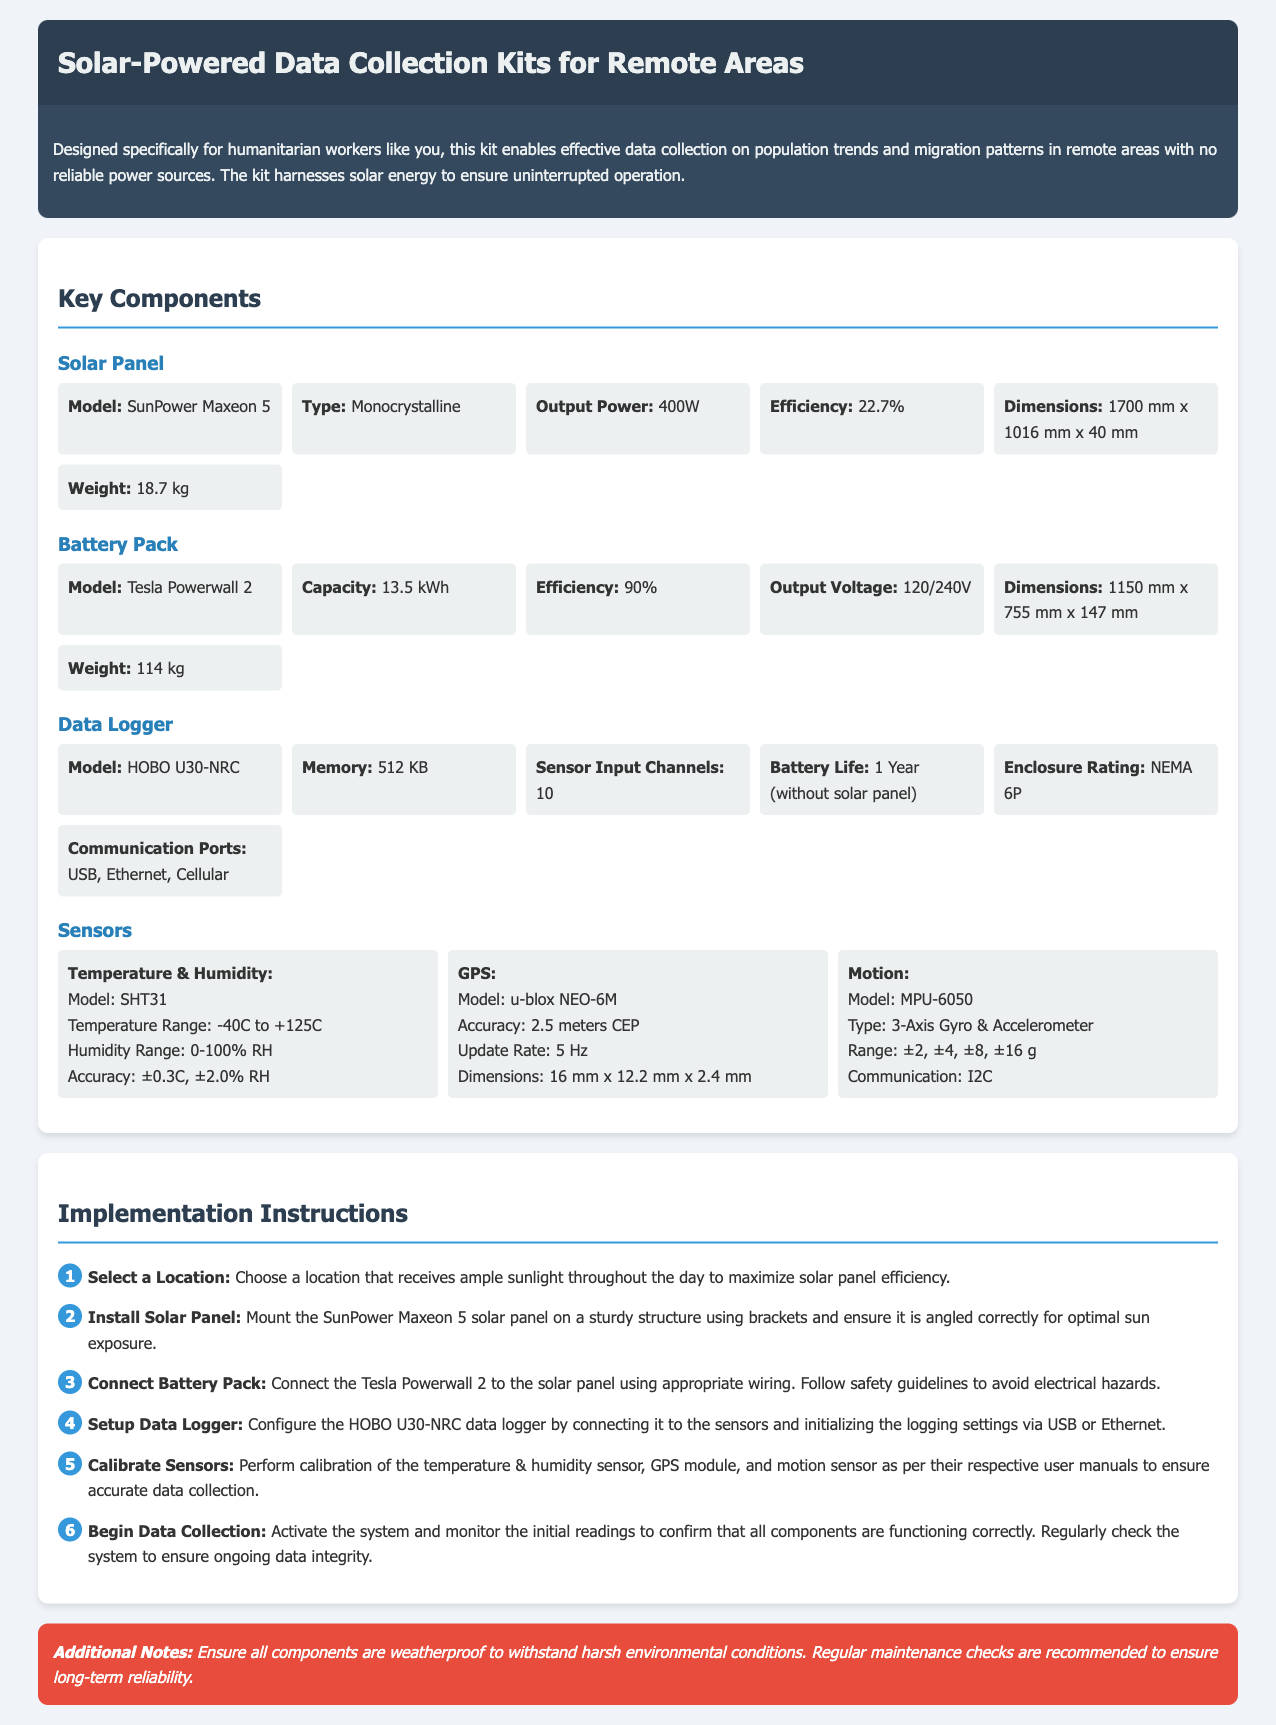what type of solar panel is used? The document specifies that the solar panel model is SunPower Maxeon 5 and it is monocrystalline in type.
Answer: Monocrystalline what is the output power of the solar panel? The output power of the solar panel is mentioned explicitly in the specifications section.
Answer: 400W what is the capacity of the battery pack? The capacity of the Tesla Powerwall 2 battery pack is provided in the specifications section.
Answer: 13.5 kWh how many sensor input channels does the data logger have? The number of sensor input channels for the HOBO U30-NRC data logger is detailed in the specifications section.
Answer: 10 what is the weight of the battery pack? The document includes the weight of the Tesla Powerwall 2 battery pack in its specifications.
Answer: 114 kg describe the first step in the implementation instructions. The first step outlines the selection of a location for setup based on sunlight exposure.
Answer: Select a Location how often should maintenance checks be performed? The additional notes section emphasizes the importance of regular maintenance checks for reliability.
Answer: Regularly what is the enclosure rating of the data logger? The enclosure rating for the HOBO U30-NRC data logger is specifically noted in the document.
Answer: NEMA 6P what is the recommended angle for the solar panel installation? The document mentions ensuring that the solar panel is angled correctly for optimal sun exposure during installation.
Answer: Optimal sun exposure 